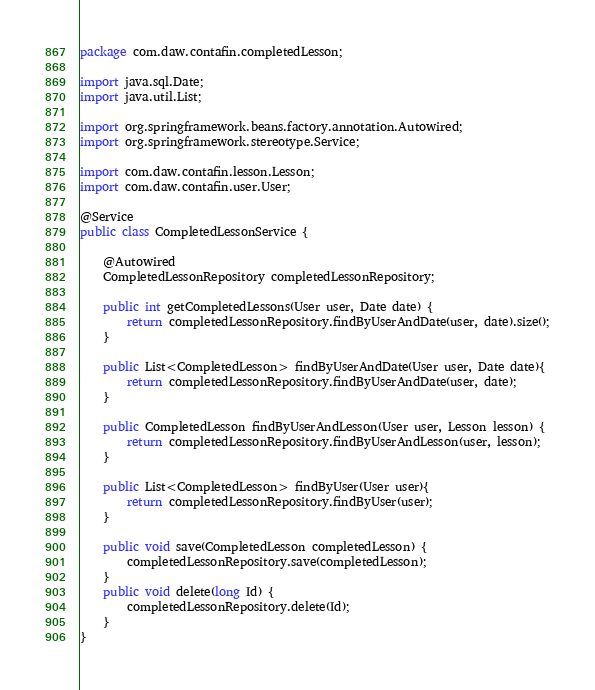Convert code to text. <code><loc_0><loc_0><loc_500><loc_500><_Java_>package com.daw.contafin.completedLesson;

import java.sql.Date;
import java.util.List;

import org.springframework.beans.factory.annotation.Autowired;
import org.springframework.stereotype.Service;

import com.daw.contafin.lesson.Lesson;
import com.daw.contafin.user.User;

@Service
public class CompletedLessonService {
	
	@Autowired
	CompletedLessonRepository completedLessonRepository;
	
	public int getCompletedLessons(User user, Date date) {
		return completedLessonRepository.findByUserAndDate(user, date).size();
	}

	public List<CompletedLesson> findByUserAndDate(User user, Date date){
		return completedLessonRepository.findByUserAndDate(user, date);
	}
	
	public CompletedLesson findByUserAndLesson(User user, Lesson lesson) {
		return completedLessonRepository.findByUserAndLesson(user, lesson);
	}
	
	public List<CompletedLesson> findByUser(User user){
		return completedLessonRepository.findByUser(user);
	}
	
	public void save(CompletedLesson completedLesson) {
		completedLessonRepository.save(completedLesson);
	}
	public void delete(long Id) {
		completedLessonRepository.delete(Id);
	}
}
</code> 